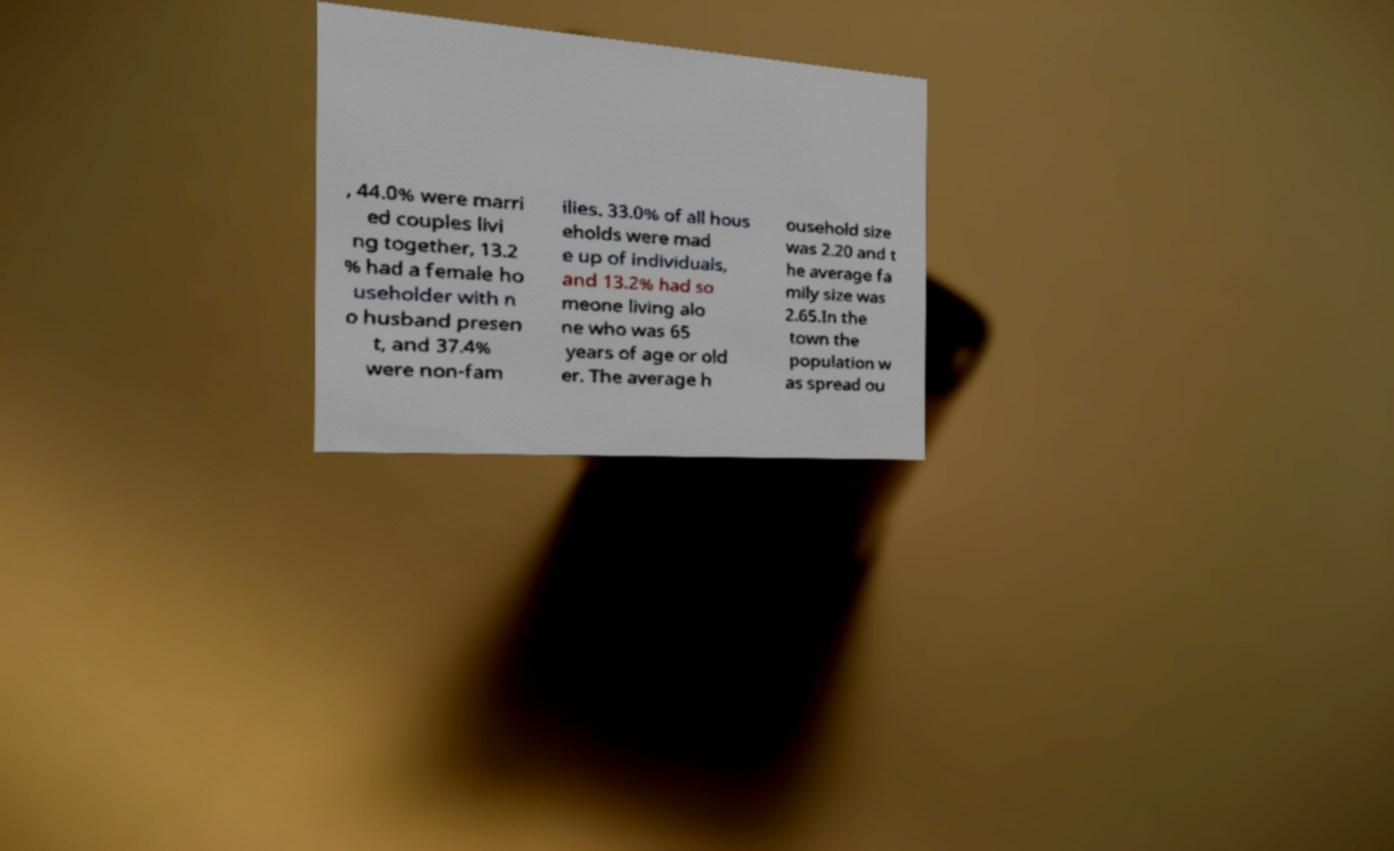I need the written content from this picture converted into text. Can you do that? , 44.0% were marri ed couples livi ng together, 13.2 % had a female ho useholder with n o husband presen t, and 37.4% were non-fam ilies. 33.0% of all hous eholds were mad e up of individuals, and 13.2% had so meone living alo ne who was 65 years of age or old er. The average h ousehold size was 2.20 and t he average fa mily size was 2.65.In the town the population w as spread ou 